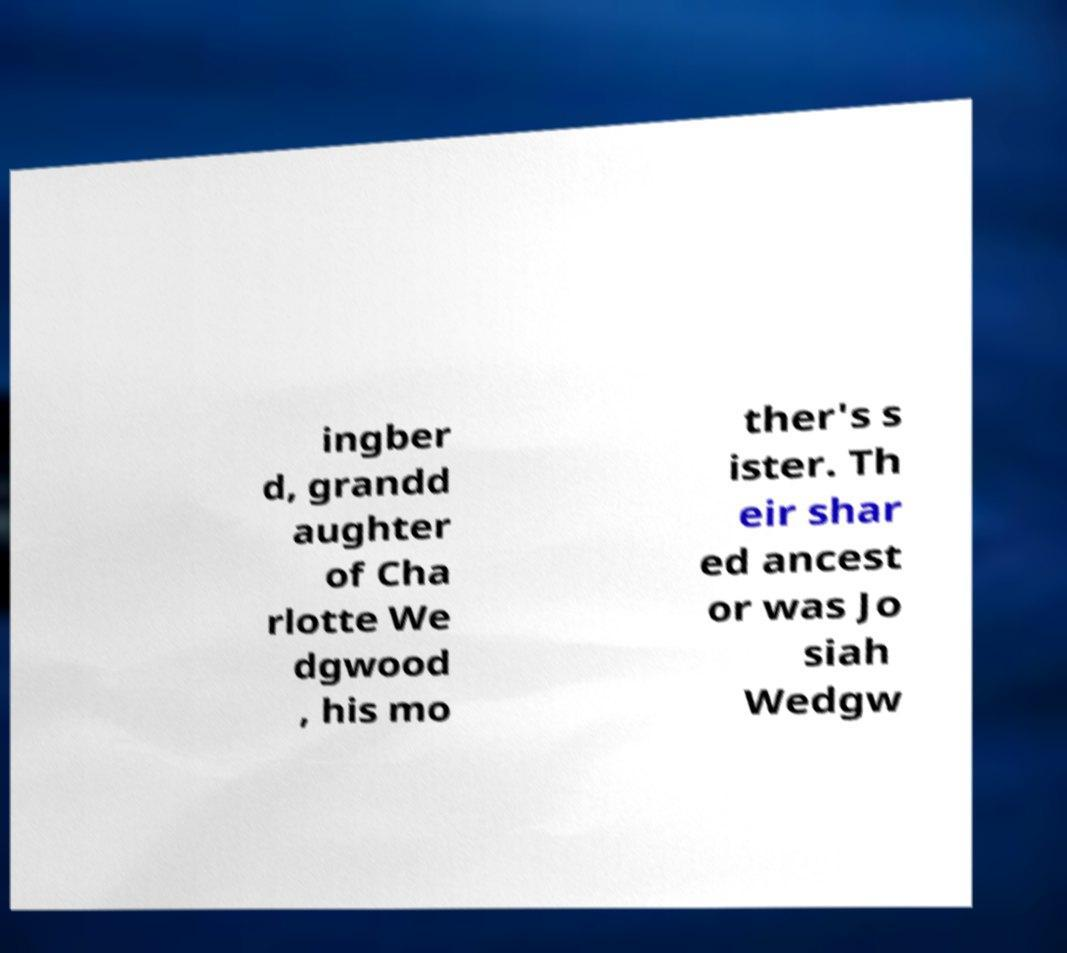Please identify and transcribe the text found in this image. ingber d, grandd aughter of Cha rlotte We dgwood , his mo ther's s ister. Th eir shar ed ancest or was Jo siah Wedgw 